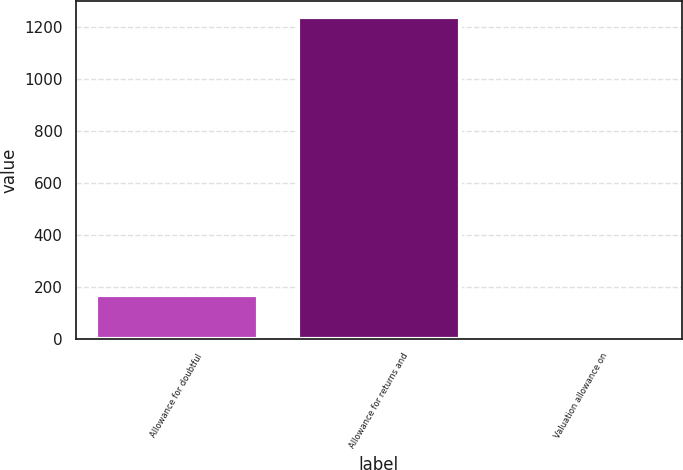Convert chart to OTSL. <chart><loc_0><loc_0><loc_500><loc_500><bar_chart><fcel>Allowance for doubtful<fcel>Allowance for returns and<fcel>Valuation allowance on<nl><fcel>166<fcel>1236<fcel>4<nl></chart> 